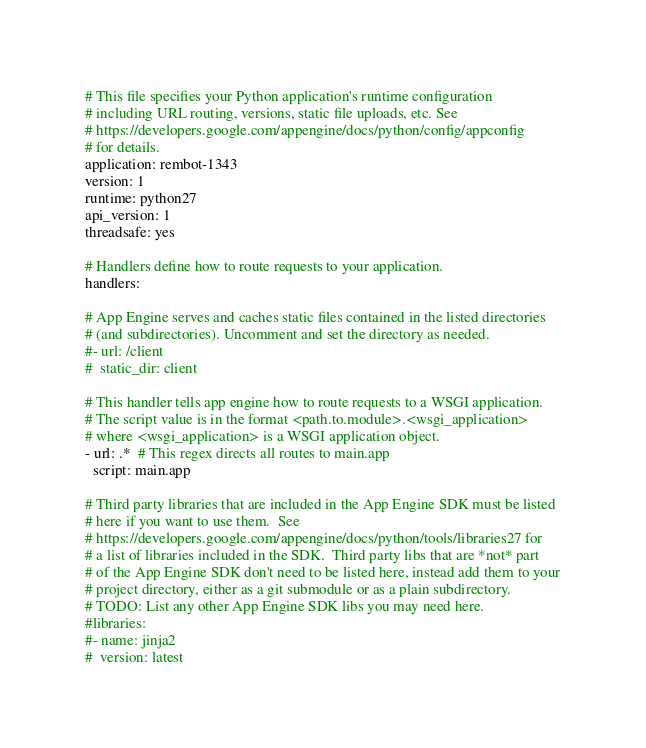<code> <loc_0><loc_0><loc_500><loc_500><_YAML_># This file specifies your Python application's runtime configuration
# including URL routing, versions, static file uploads, etc. See
# https://developers.google.com/appengine/docs/python/config/appconfig
# for details.
application: rembot-1343
version: 1
runtime: python27
api_version: 1
threadsafe: yes

# Handlers define how to route requests to your application.
handlers:

# App Engine serves and caches static files contained in the listed directories
# (and subdirectories). Uncomment and set the directory as needed.
#- url: /client
#  static_dir: client

# This handler tells app engine how to route requests to a WSGI application.
# The script value is in the format <path.to.module>.<wsgi_application>
# where <wsgi_application> is a WSGI application object.
- url: .*  # This regex directs all routes to main.app
  script: main.app

# Third party libraries that are included in the App Engine SDK must be listed
# here if you want to use them.  See
# https://developers.google.com/appengine/docs/python/tools/libraries27 for
# a list of libraries included in the SDK.  Third party libs that are *not* part
# of the App Engine SDK don't need to be listed here, instead add them to your
# project directory, either as a git submodule or as a plain subdirectory.
# TODO: List any other App Engine SDK libs you may need here.
#libraries:
#- name: jinja2
#  version: latest
</code> 